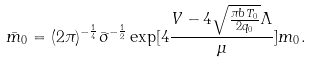Convert formula to latex. <formula><loc_0><loc_0><loc_500><loc_500>\bar { m } _ { 0 } = ( 2 \pi ) ^ { - \frac { 1 } { 4 } } \bar { \sigma } ^ { - \frac { 1 } { 2 } } \exp [ 4 \frac { V - 4 \sqrt { \frac { \pi b T _ { 0 } } { 2 q _ { 0 } } } \Lambda } { \mu } ] m _ { 0 } .</formula> 